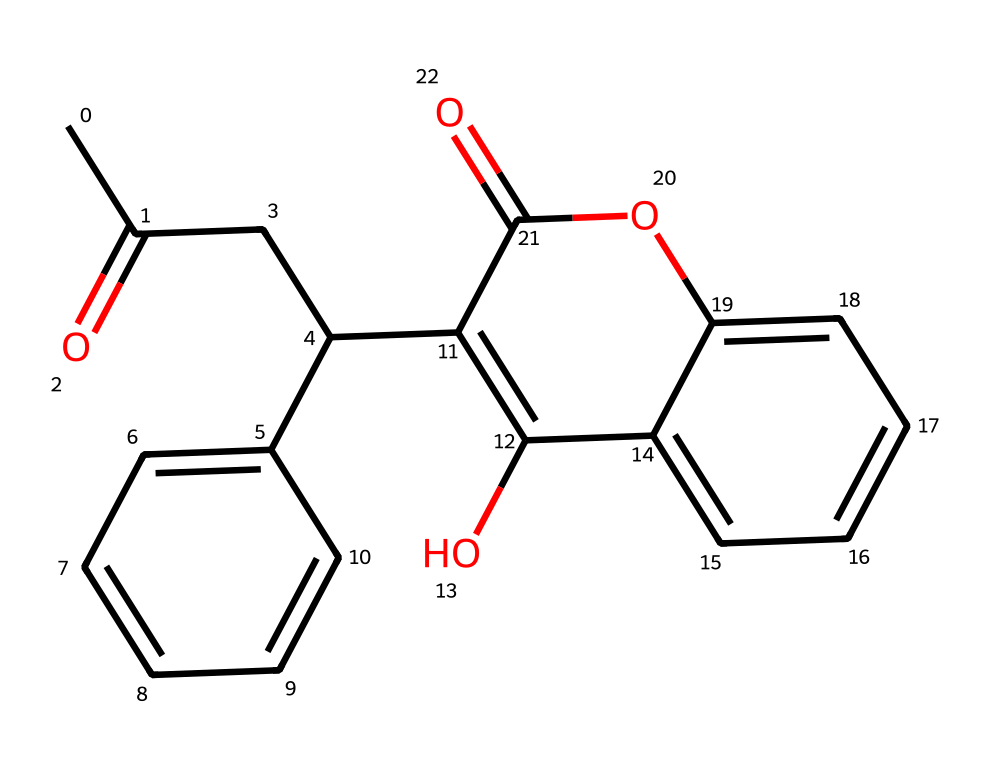What is the main functional group present in warfarin? The chemical structure of warfarin contains a ketone functional group indicated by the carbonyl (C=O) found in the carbon chain as well as an ether (O) within its cyclic portion.
Answer: ketone How many aromatic rings are present in this chemical structure? By analyzing the chemical structure, it is evident that there are two distinct aromatic rings present, both indicated by alternating double bonds in the cyclic areas of the structure.
Answer: 2 What is the role of warfarin in pest control? Warfarin is used as an anticoagulant rodenticide, which means it prevents blood clotting and leads to fatal hemorrhage in rodents when consumed.
Answer: anticoagulant How many oxygen atoms are in the warfarin molecule? Upon examining the structure, there are three oxygen atoms present within the molecule, visible in the bicyclic component and as part of the functional groups.
Answer: 3 What type of pesticide classification does warfarin belong to? Warfarin is classified as a rodenticide, which is a specific type of pesticide designed to target rodent populations effectively.
Answer: rodenticide What is a potential environmental concern when using warfarin? One significant environmental concern arises from the risk of secondary poisoning, where non-target species, like predators, can be affected by consuming poisoned rodents that have ingested warfarin.
Answer: secondary poisoning 